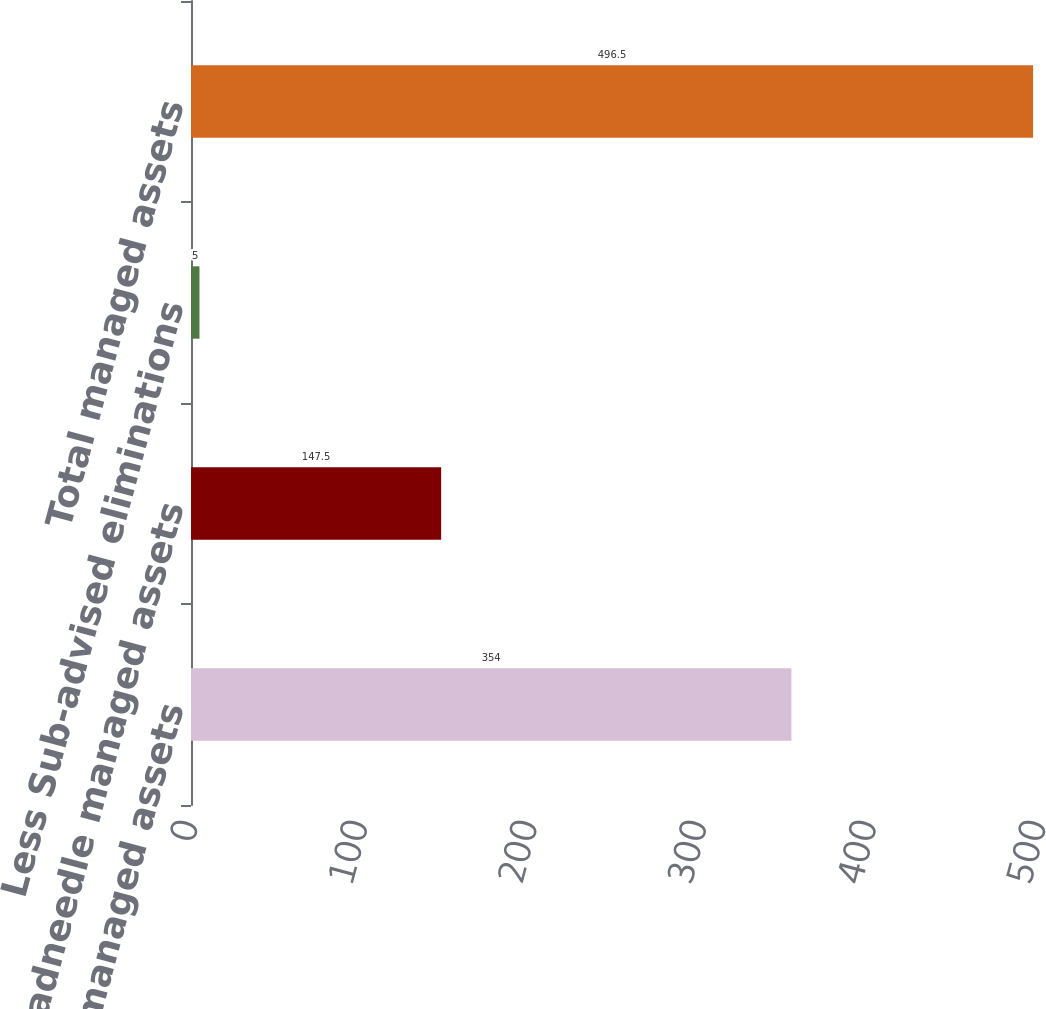Convert chart to OTSL. <chart><loc_0><loc_0><loc_500><loc_500><bar_chart><fcel>Columbia managed assets<fcel>Threadneedle managed assets<fcel>Less Sub-advised eliminations<fcel>Total managed assets<nl><fcel>354<fcel>147.5<fcel>5<fcel>496.5<nl></chart> 